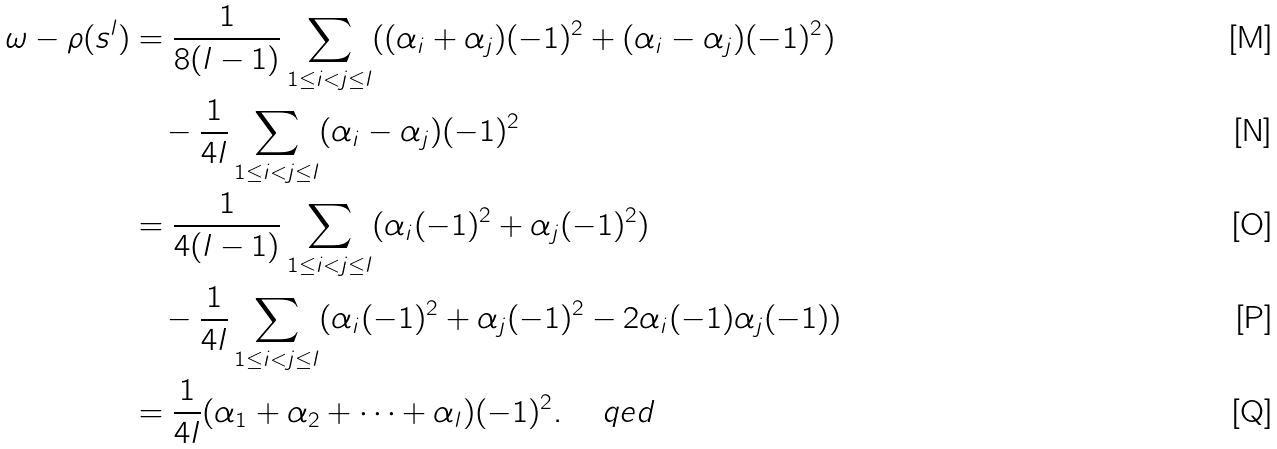<formula> <loc_0><loc_0><loc_500><loc_500>\omega - \rho ( s ^ { l } ) & = \frac { 1 } { 8 ( l - 1 ) } \sum _ { 1 \leq i < j \leq l } ( ( \alpha _ { i } + \alpha _ { j } ) ( - 1 ) ^ { 2 } + ( \alpha _ { i } - \alpha _ { j } ) ( - 1 ) ^ { 2 } ) \\ \ & \quad - \frac { 1 } { 4 l } \sum _ { 1 \leq i < j \leq l } ( \alpha _ { i } - \alpha _ { j } ) ( - 1 ) ^ { 2 } \\ \ & = \frac { 1 } { 4 ( l - 1 ) } \sum _ { 1 \leq i < j \leq l } ( \alpha _ { i } ( - 1 ) ^ { 2 } + \alpha _ { j } ( - 1 ) ^ { 2 } ) \\ \ & \quad - \frac { 1 } { 4 l } \sum _ { 1 \leq i < j \leq l } ( \alpha _ { i } ( - 1 ) ^ { 2 } + \alpha _ { j } ( - 1 ) ^ { 2 } - 2 \alpha _ { i } ( - 1 ) \alpha _ { j } ( - 1 ) ) \\ \ & = \frac { 1 } { 4 l } ( \alpha _ { 1 } + \alpha _ { 2 } + \cdots + \alpha _ { l } ) ( - 1 ) ^ { 2 } . \quad \ q e d</formula> 